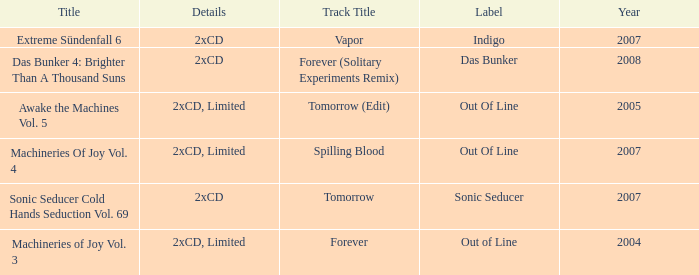What average year contains the title of machineries of joy vol. 4? 2007.0. 